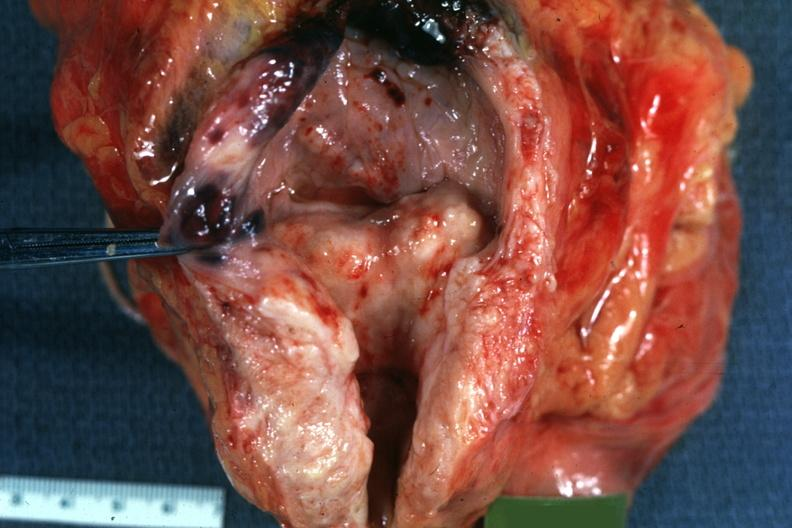what is present?
Answer the question using a single word or phrase. Prostate 